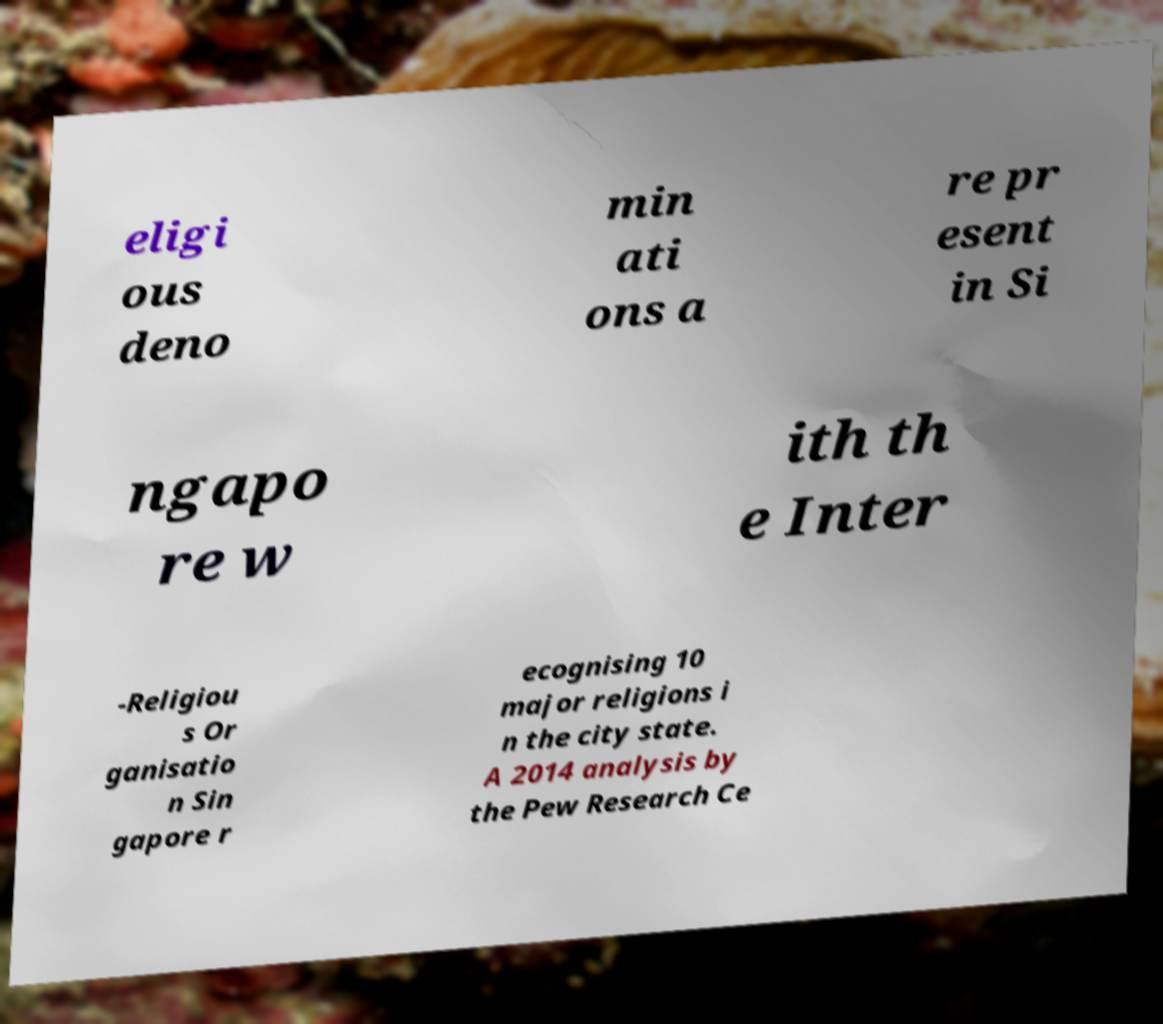There's text embedded in this image that I need extracted. Can you transcribe it verbatim? eligi ous deno min ati ons a re pr esent in Si ngapo re w ith th e Inter -Religiou s Or ganisatio n Sin gapore r ecognising 10 major religions i n the city state. A 2014 analysis by the Pew Research Ce 